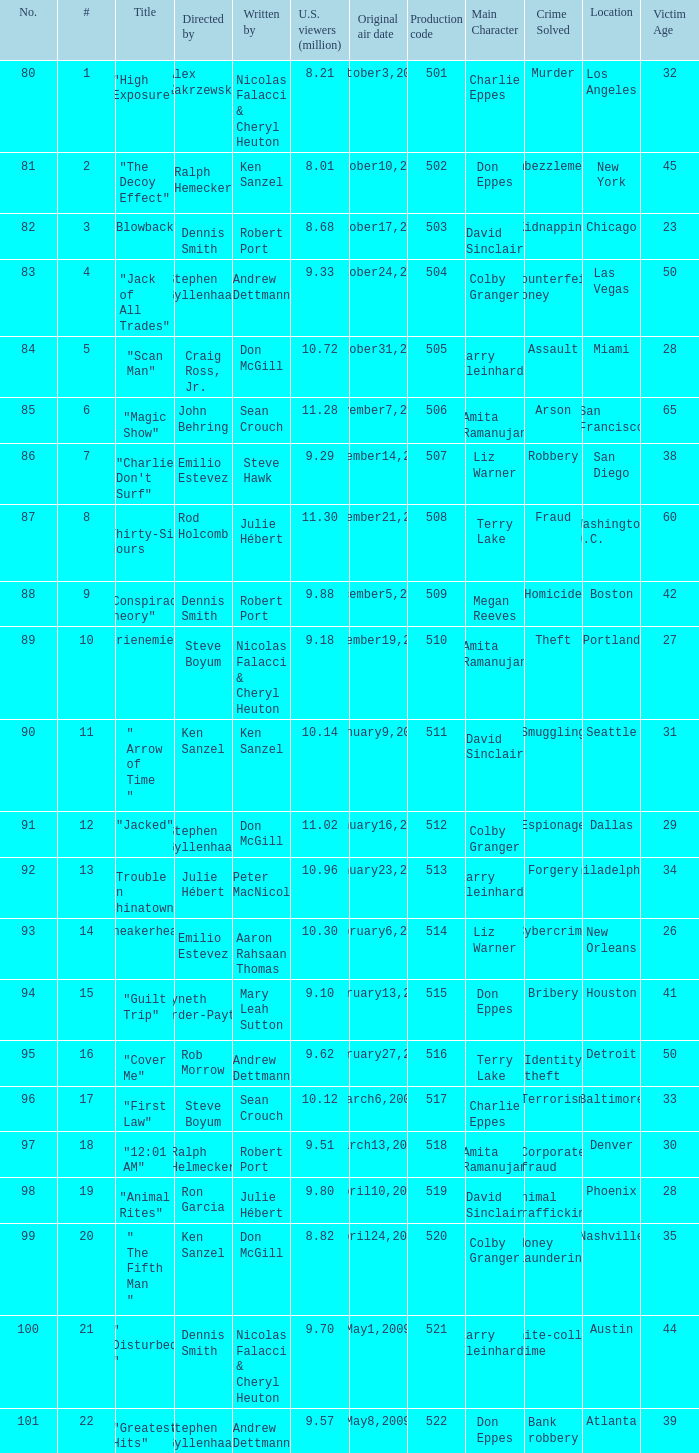Parse the full table. {'header': ['No.', '#', 'Title', 'Directed by', 'Written by', 'U.S. viewers (million)', 'Original air date', 'Production code', 'Main Character', 'Crime Solved', 'Location', 'Victim Age'], 'rows': [['80', '1', '"High Exposure"', 'Alex Zakrzewski', 'Nicolas Falacci & Cheryl Heuton', '8.21', 'October3,2008', '501', 'Charlie Eppes', 'Murder', 'Los Angeles', '32'], ['81', '2', '"The Decoy Effect"', 'Ralph Hemecker', 'Ken Sanzel', '8.01', 'October10,2008', '502', 'Don Eppes', 'Embezzlement', 'New York', '45'], ['82', '3', '"Blowback"', 'Dennis Smith', 'Robert Port', '8.68', 'October17,2008', '503', 'David Sinclair', 'Kidnapping', 'Chicago', '23'], ['83', '4', '"Jack of All Trades"', 'Stephen Gyllenhaal', 'Andrew Dettmann', '9.33', 'October24,2008', '504', 'Colby Granger', 'Counterfeit money', 'Las Vegas', '50'], ['84', '5', '"Scan Man"', 'Craig Ross, Jr.', 'Don McGill', '10.72', 'October31,2008', '505', 'Larry Fleinhardt', 'Assault', 'Miami', '28'], ['85', '6', '"Magic Show"', 'John Behring', 'Sean Crouch', '11.28', 'November7,2008', '506', 'Amita Ramanujan', 'Arson', 'San Francisco', '65'], ['86', '7', '"Charlie Don\'t Surf"', 'Emilio Estevez', 'Steve Hawk', '9.29', 'November14,2008', '507', 'Liz Warner', 'Robbery', 'San Diego', '38'], ['87', '8', '" Thirty-Six Hours "', 'Rod Holcomb', 'Julie Hébert', '11.30', 'November21,2008', '508', 'Terry Lake', 'Fraud', 'Washington D.C.', '60'], ['88', '9', '"Conspiracy Theory"', 'Dennis Smith', 'Robert Port', '9.88', 'December5,2008', '509', 'Megan Reeves', 'Homicide', 'Boston', '42'], ['89', '10', '"Frienemies"', 'Steve Boyum', 'Nicolas Falacci & Cheryl Heuton', '9.18', 'December19,2008', '510', 'Amita Ramanujan', 'Theft', 'Portland', '27'], ['90', '11', '" Arrow of Time "', 'Ken Sanzel', 'Ken Sanzel', '10.14', 'January9,2009', '511', 'David Sinclair', 'Smuggling', 'Seattle', '31'], ['91', '12', '"Jacked"', 'Stephen Gyllenhaal', 'Don McGill', '11.02', 'January16,2009', '512', 'Colby Granger', 'Espionage', 'Dallas', '29'], ['92', '13', '"Trouble In Chinatown"', 'Julie Hébert', 'Peter MacNicol', '10.96', 'January23,2009', '513', 'Larry Fleinhardt', 'Forgery', 'Philadelphia', '34'], ['93', '14', '"Sneakerhead"', 'Emilio Estevez', 'Aaron Rahsaan Thomas', '10.30', 'February6,2009', '514', 'Liz Warner', 'Cybercrime', 'New Orleans', '26'], ['94', '15', '"Guilt Trip"', 'Gwyneth Horder-Payton', 'Mary Leah Sutton', '9.10', 'February13,2009', '515', 'Don Eppes', 'Bribery', 'Houston', '41'], ['95', '16', '"Cover Me"', 'Rob Morrow', 'Andrew Dettmann', '9.62', 'February27,2009', '516', 'Terry Lake', 'Identity theft', 'Detroit', '50'], ['96', '17', '"First Law"', 'Steve Boyum', 'Sean Crouch', '10.12', 'March6,2009', '517', 'Charlie Eppes', 'Terrorism', 'Baltimore', '33'], ['97', '18', '"12:01 AM"', 'Ralph Helmecker', 'Robert Port', '9.51', 'March13,2009', '518', 'Amita Ramanujan', 'Corporate fraud', 'Denver', '30'], ['98', '19', '"Animal Rites"', 'Ron Garcia', 'Julie Hébert', '9.80', 'April10,2009', '519', 'David Sinclair', 'Animal trafficking', 'Phoenix', '28'], ['99', '20', '" The Fifth Man "', 'Ken Sanzel', 'Don McGill', '8.82', 'April24,2009', '520', 'Colby Granger', 'Money laundering', 'Nashville', '35'], ['100', '21', '" Disturbed "', 'Dennis Smith', 'Nicolas Falacci & Cheryl Heuton', '9.70', 'May1,2009', '521', 'Larry Fleinhardt', 'White-collar crime', 'Austin', '44'], ['101', '22', '"Greatest Hits"', 'Stephen Gyllenhaal', 'Andrew Dettmann', '9.57', 'May8,2009', '522', 'Don Eppes', 'Bank robbery', 'Atlanta', '39']]} What episode had 10.14 million viewers (U.S.)? 11.0. 